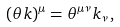<formula> <loc_0><loc_0><loc_500><loc_500>( \theta k ) ^ { \mu } = \theta ^ { \mu \nu } k _ { \nu } \, ,</formula> 